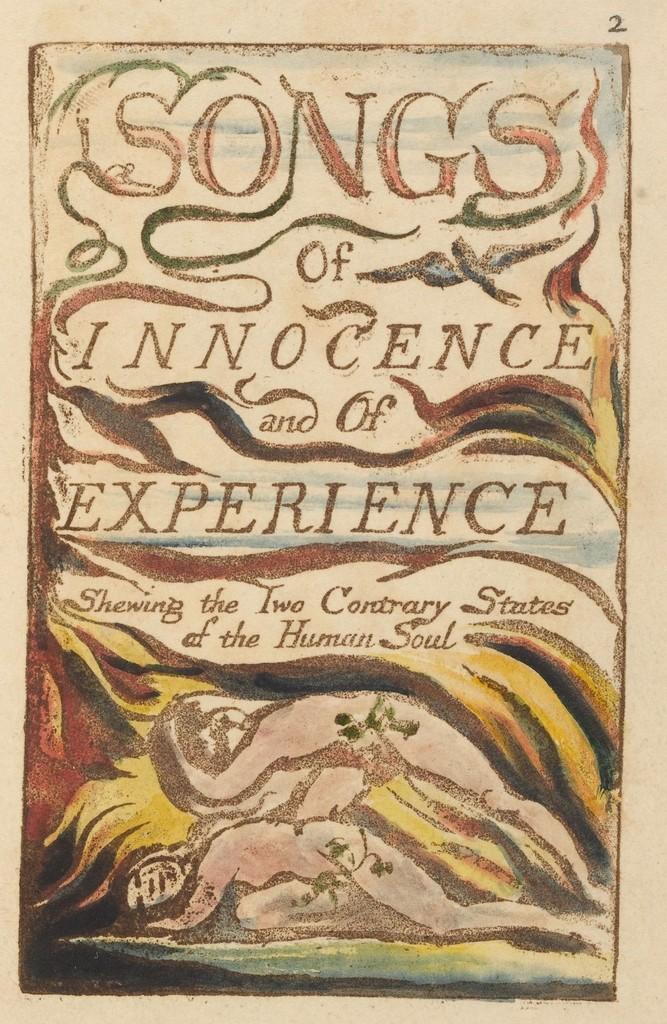What is the title?
Your answer should be very brief. Songs of innocence and of experience. What kind of soul?
Ensure brevity in your answer.  Human. 